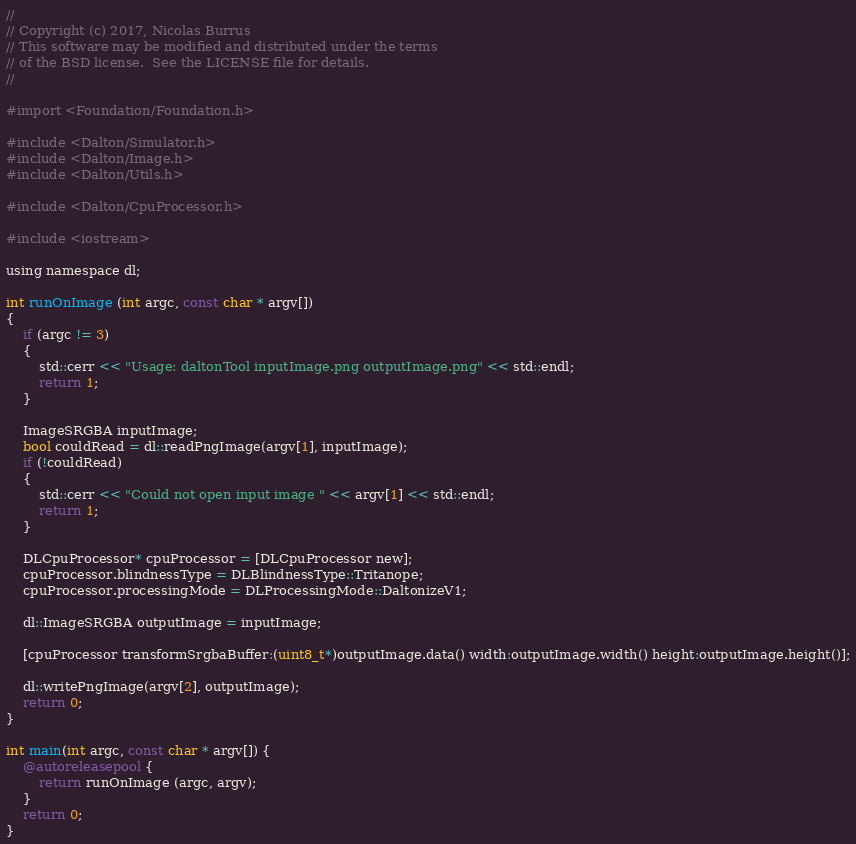Convert code to text. <code><loc_0><loc_0><loc_500><loc_500><_ObjectiveC_>//
// Copyright (c) 2017, Nicolas Burrus
// This software may be modified and distributed under the terms
// of the BSD license.  See the LICENSE file for details.
//

#import <Foundation/Foundation.h>

#include <Dalton/Simulator.h>
#include <Dalton/Image.h>
#include <Dalton/Utils.h>

#include <Dalton/CpuProcessor.h>

#include <iostream>

using namespace dl;

int runOnImage (int argc, const char * argv[])
{
    if (argc != 3)
    {
        std::cerr << "Usage: daltonTool inputImage.png outputImage.png" << std::endl;
        return 1;
    }
    
    ImageSRGBA inputImage;
    bool couldRead = dl::readPngImage(argv[1], inputImage);
    if (!couldRead)
    {
        std::cerr << "Could not open input image " << argv[1] << std::endl;
        return 1;
    }
    
    DLCpuProcessor* cpuProcessor = [DLCpuProcessor new];
    cpuProcessor.blindnessType = DLBlindnessType::Tritanope;
    cpuProcessor.processingMode = DLProcessingMode::DaltonizeV1;
    
    dl::ImageSRGBA outputImage = inputImage;
    
    [cpuProcessor transformSrgbaBuffer:(uint8_t*)outputImage.data() width:outputImage.width() height:outputImage.height()];
    
    dl::writePngImage(argv[2], outputImage);
    return 0;
}

int main(int argc, const char * argv[]) {
    @autoreleasepool {
        return runOnImage (argc, argv);
    }
    return 0;
}
</code> 